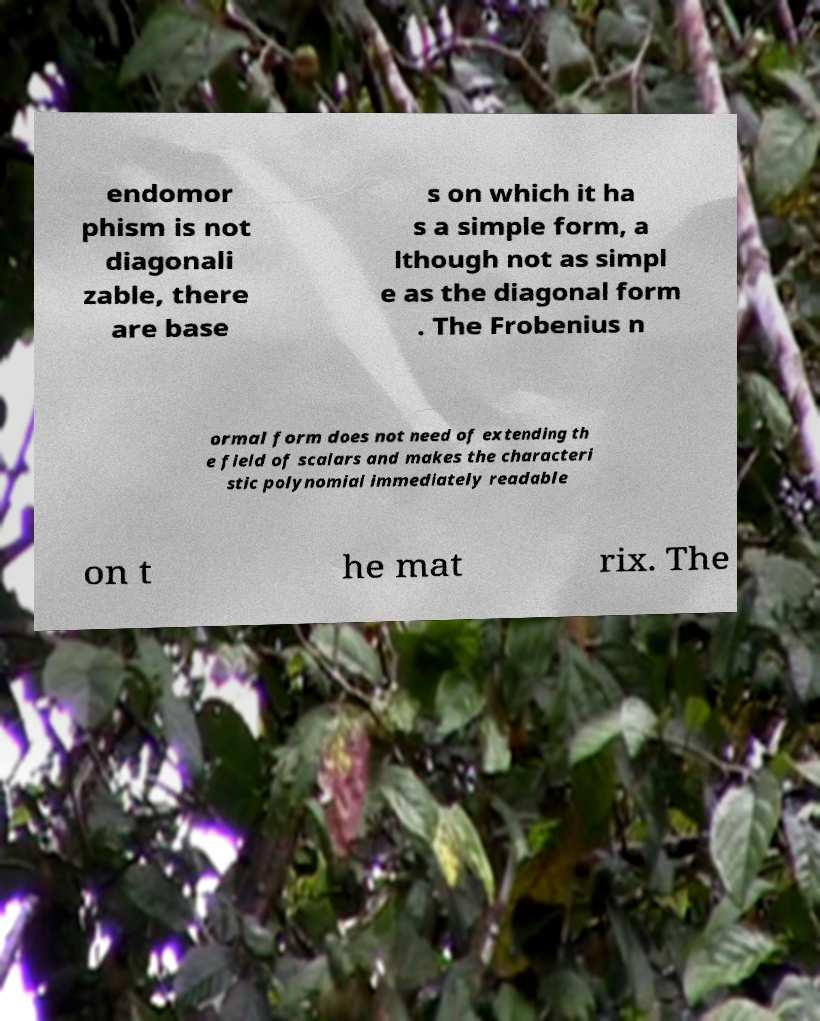I need the written content from this picture converted into text. Can you do that? endomor phism is not diagonali zable, there are base s on which it ha s a simple form, a lthough not as simpl e as the diagonal form . The Frobenius n ormal form does not need of extending th e field of scalars and makes the characteri stic polynomial immediately readable on t he mat rix. The 